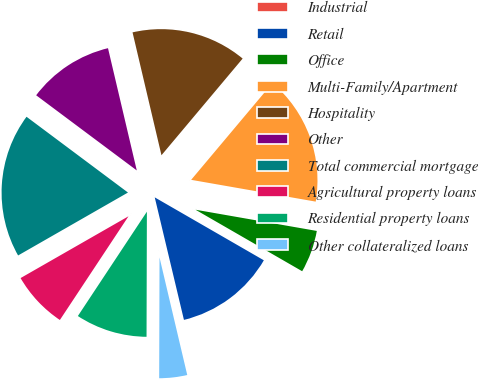Convert chart. <chart><loc_0><loc_0><loc_500><loc_500><pie_chart><fcel>Industrial<fcel>Retail<fcel>Office<fcel>Multi-Family/Apartment<fcel>Hospitality<fcel>Other<fcel>Total commercial mortgage<fcel>Agricultural property loans<fcel>Residential property loans<fcel>Other collateralized loans<nl><fcel>0.04%<fcel>12.95%<fcel>5.57%<fcel>16.64%<fcel>14.8%<fcel>11.11%<fcel>18.49%<fcel>7.42%<fcel>9.26%<fcel>3.73%<nl></chart> 